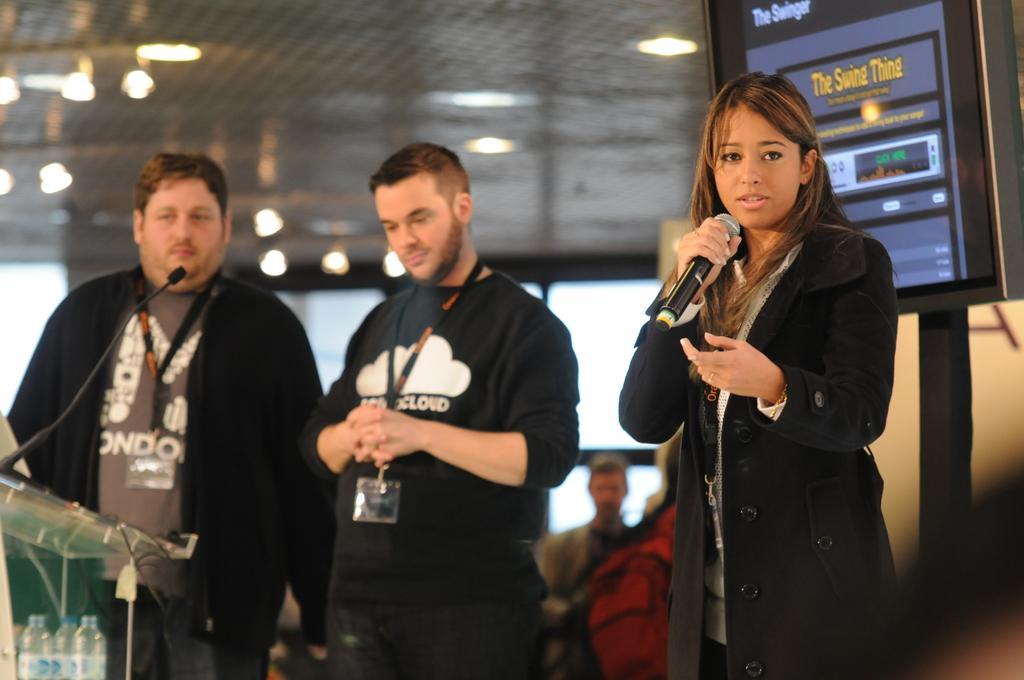Please provide a concise description of this image. This picture is of inside. On the right there is a woman wearing black color dress, holding a microphone, standing and seems to be talking, behind her there is a digital screen attached to the stand. On the left there is a man standing and there is a microphone attached to the table and we can see the water bottles. In the center there is a man wearing black color t-shirt and standing. In the background we can see the lights and some group of people. 